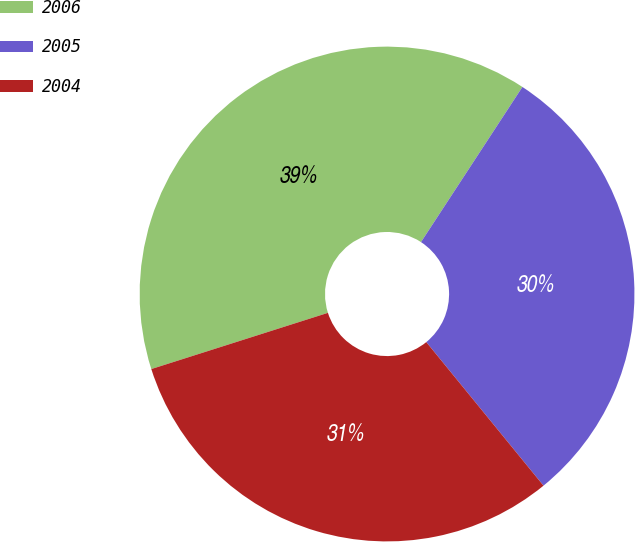Convert chart. <chart><loc_0><loc_0><loc_500><loc_500><pie_chart><fcel>2006<fcel>2005<fcel>2004<nl><fcel>39.12%<fcel>29.89%<fcel>30.99%<nl></chart> 